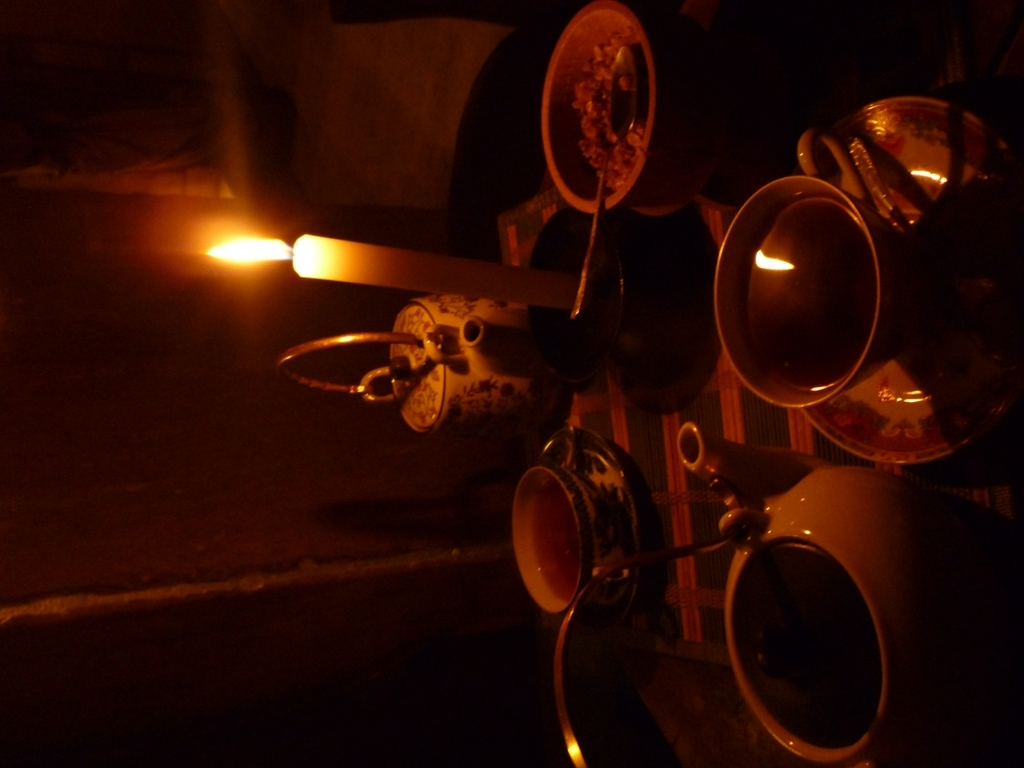What might be the occasion for setting up such a table arrangement with candles and tea? This arrangement can be associated with a personal gathering or a small celebration that emphasizes intimacy and warmth. The teacups and pot suggest a tea session, which could be a part of a cultural ritual or simply a casual, reflective moment shared between close friends or family. The candles indicate an evening event or a desire to create a peaceful retreat from the busyness of day-to-day life. 